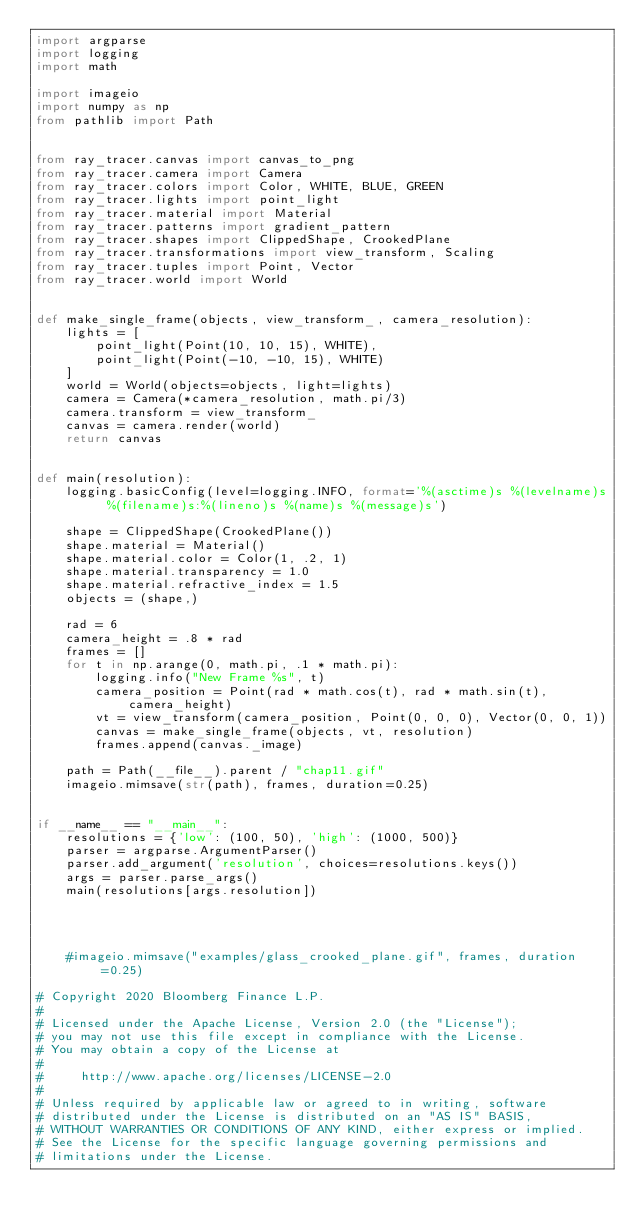<code> <loc_0><loc_0><loc_500><loc_500><_Python_>import argparse
import logging
import math

import imageio
import numpy as np
from pathlib import Path


from ray_tracer.canvas import canvas_to_png
from ray_tracer.camera import Camera
from ray_tracer.colors import Color, WHITE, BLUE, GREEN
from ray_tracer.lights import point_light
from ray_tracer.material import Material
from ray_tracer.patterns import gradient_pattern
from ray_tracer.shapes import ClippedShape, CrookedPlane
from ray_tracer.transformations import view_transform, Scaling
from ray_tracer.tuples import Point, Vector
from ray_tracer.world import World


def make_single_frame(objects, view_transform_, camera_resolution):
    lights = [
        point_light(Point(10, 10, 15), WHITE),
        point_light(Point(-10, -10, 15), WHITE)
    ]
    world = World(objects=objects, light=lights)
    camera = Camera(*camera_resolution, math.pi/3)
    camera.transform = view_transform_
    canvas = camera.render(world)
    return canvas


def main(resolution):
    logging.basicConfig(level=logging.INFO, format='%(asctime)s %(levelname)s %(filename)s:%(lineno)s %(name)s %(message)s')

    shape = ClippedShape(CrookedPlane())
    shape.material = Material()
    shape.material.color = Color(1, .2, 1)
    shape.material.transparency = 1.0
    shape.material.refractive_index = 1.5
    objects = (shape,)

    rad = 6
    camera_height = .8 * rad
    frames = []
    for t in np.arange(0, math.pi, .1 * math.pi):
        logging.info("New Frame %s", t)
        camera_position = Point(rad * math.cos(t), rad * math.sin(t), camera_height)
        vt = view_transform(camera_position, Point(0, 0, 0), Vector(0, 0, 1))
        canvas = make_single_frame(objects, vt, resolution)
        frames.append(canvas._image)

    path = Path(__file__).parent / "chap11.gif"
    imageio.mimsave(str(path), frames, duration=0.25)


if __name__ == "__main__":
    resolutions = {'low': (100, 50), 'high': (1000, 500)}
    parser = argparse.ArgumentParser()
    parser.add_argument('resolution', choices=resolutions.keys())
    args = parser.parse_args()
    main(resolutions[args.resolution])


 

    #imageio.mimsave("examples/glass_crooked_plane.gif", frames, duration=0.25)

# Copyright 2020 Bloomberg Finance L.P.
#
# Licensed under the Apache License, Version 2.0 (the "License");
# you may not use this file except in compliance with the License.
# You may obtain a copy of the License at
#
#     http://www.apache.org/licenses/LICENSE-2.0
#
# Unless required by applicable law or agreed to in writing, software
# distributed under the License is distributed on an "AS IS" BASIS,
# WITHOUT WARRANTIES OR CONDITIONS OF ANY KIND, either express or implied.
# See the License for the specific language governing permissions and
# limitations under the License.
</code> 